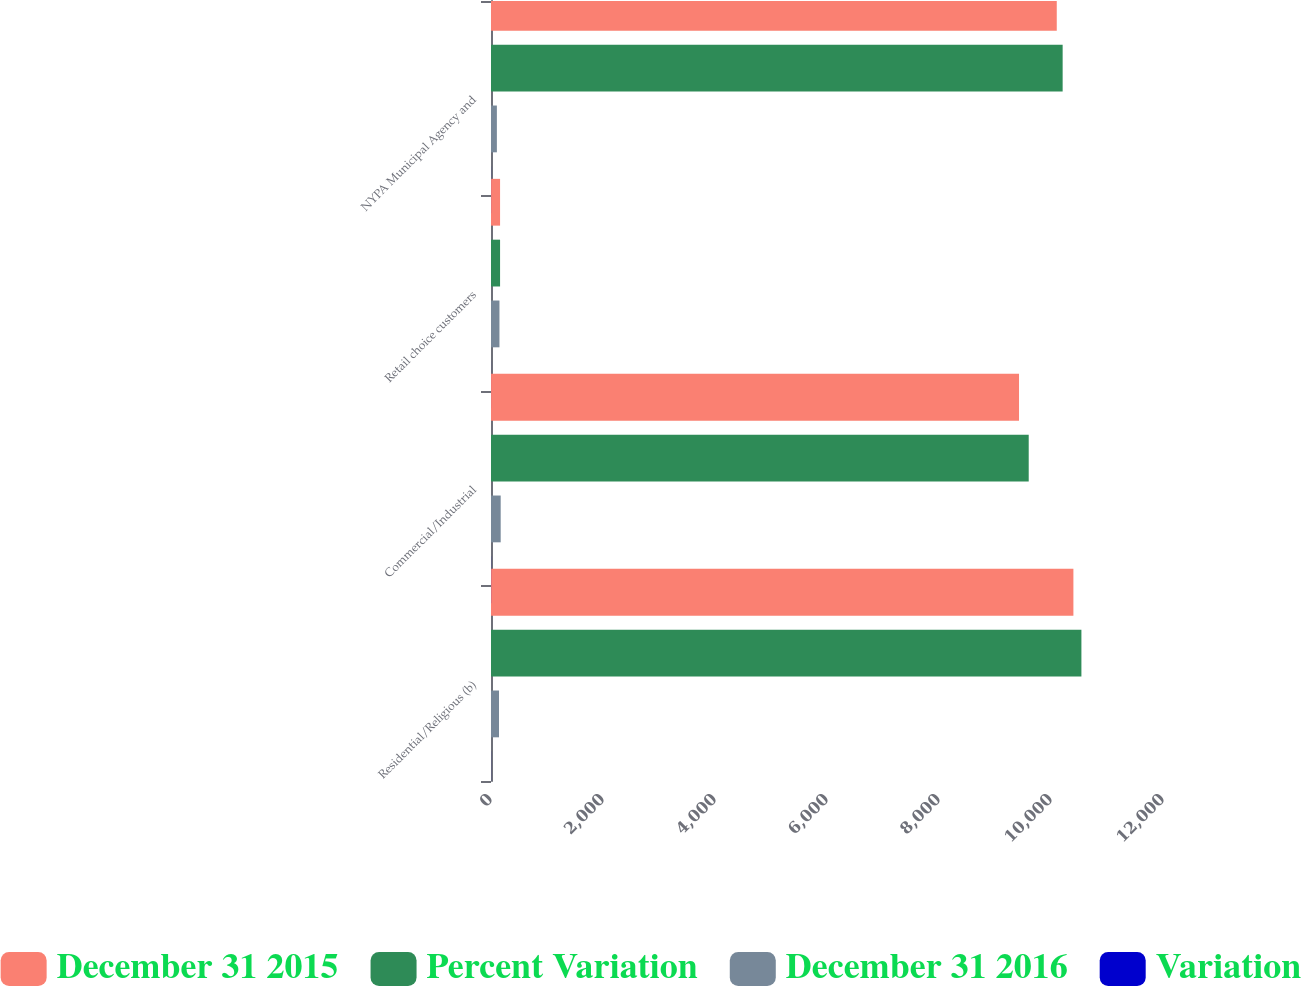<chart> <loc_0><loc_0><loc_500><loc_500><stacked_bar_chart><ecel><fcel>Residential/Religious (b)<fcel>Commercial/Industrial<fcel>Retail choice customers<fcel>NYPA Municipal Agency and<nl><fcel>December 31 2015<fcel>10400<fcel>9429<fcel>162<fcel>10103<nl><fcel>Percent Variation<fcel>10543<fcel>9602<fcel>162<fcel>10208<nl><fcel>December 31 2016<fcel>143<fcel>173<fcel>151<fcel>105<nl><fcel>Variation<fcel>1.4<fcel>1.8<fcel>0.6<fcel>1<nl></chart> 